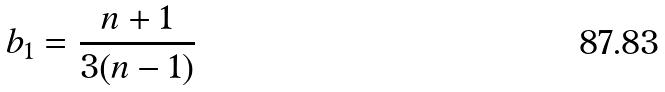<formula> <loc_0><loc_0><loc_500><loc_500>b _ { 1 } = \frac { n + 1 } { 3 ( n - 1 ) }</formula> 